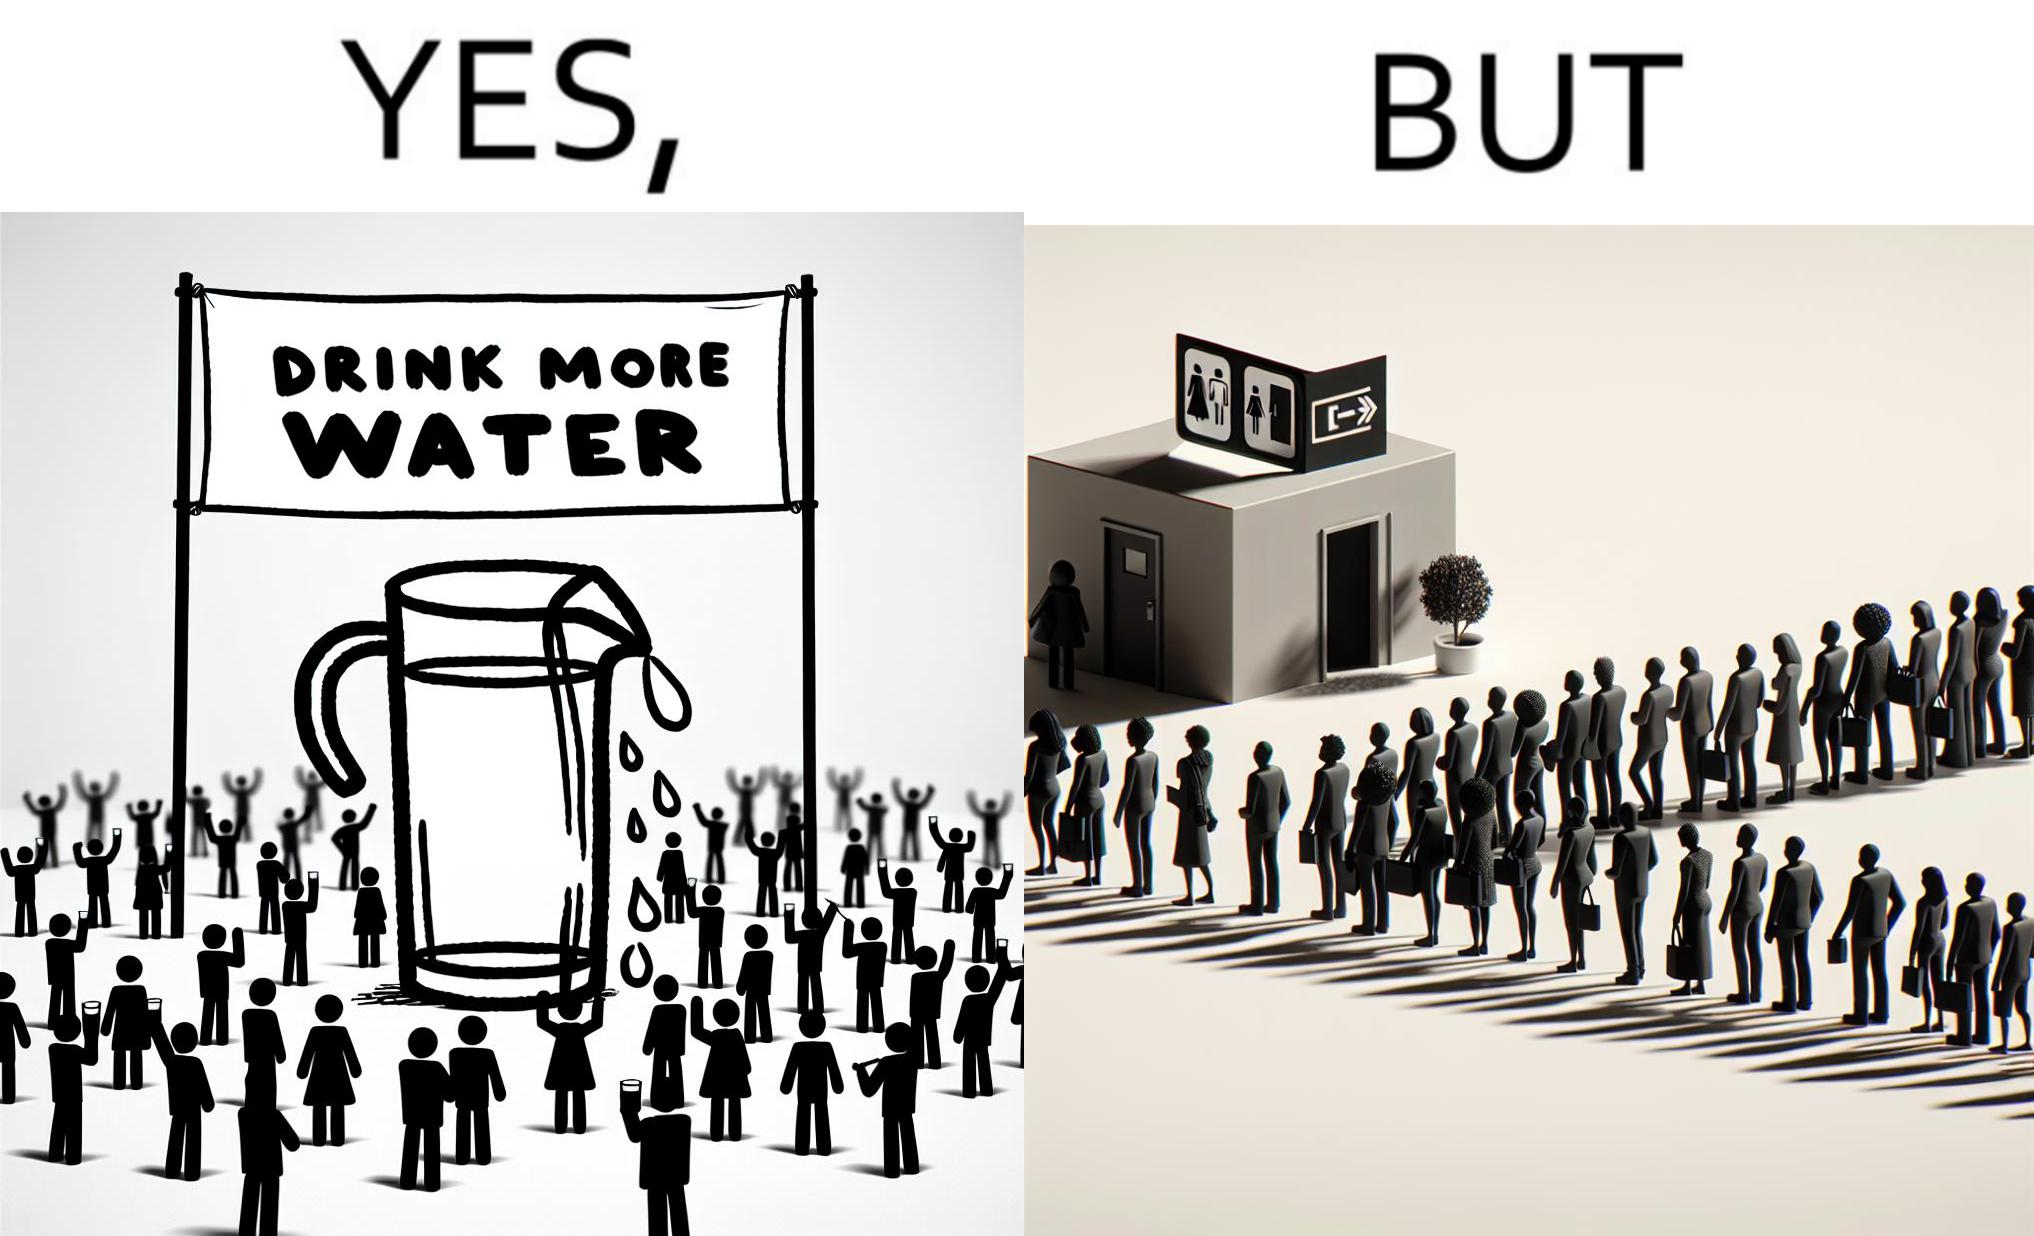Is this image satirical or non-satirical? Yes, this image is satirical. 